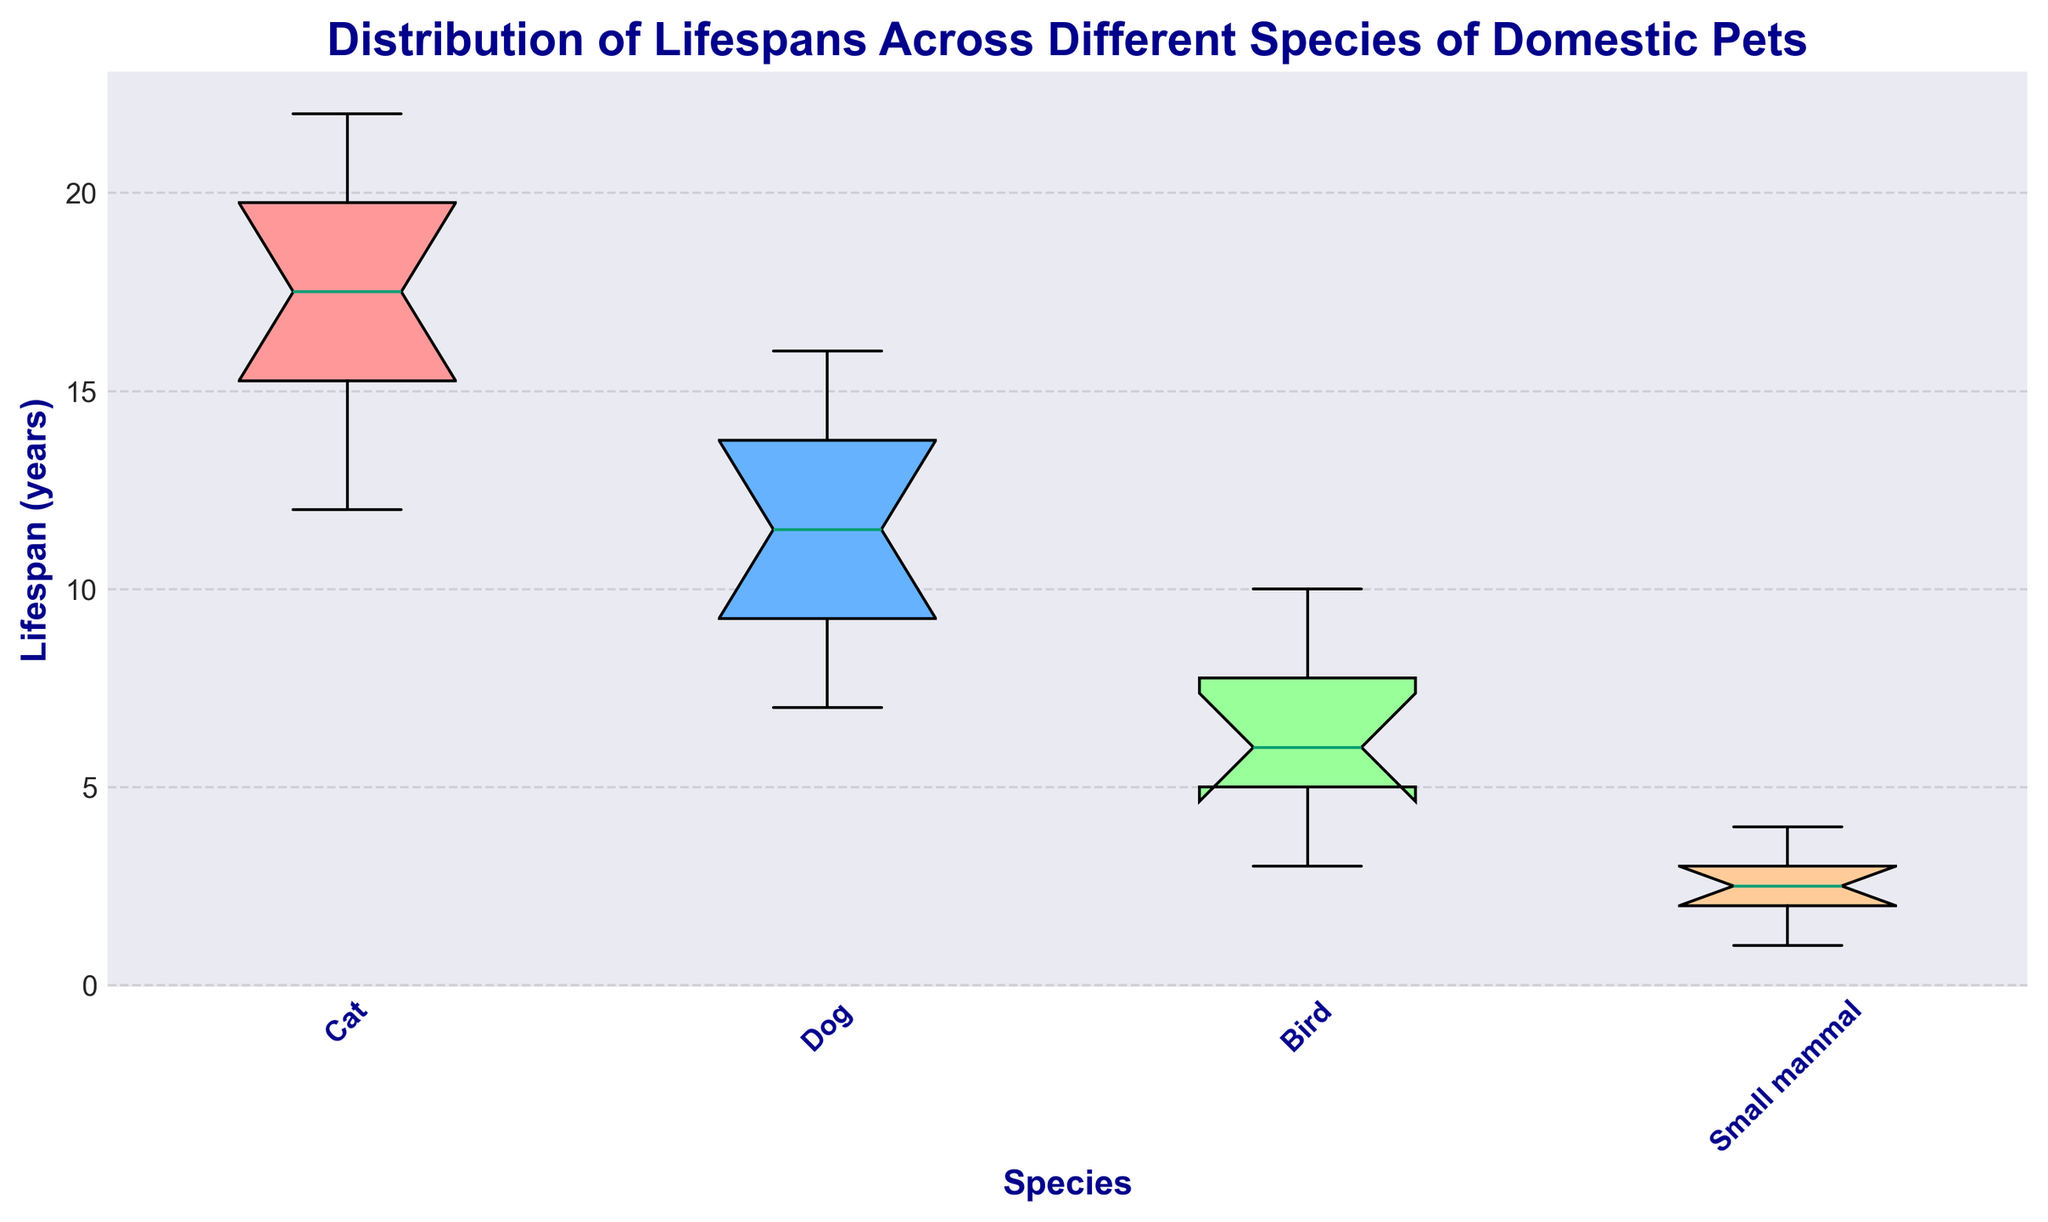What is the median lifespan of cats? The box plot displays the median value as the line inside the box for cats. Locate the box plot for cats and note the value where the line inside the box falls.
Answer: 18 Which species has the highest median lifespan? Compare the line inside the boxes of all species to identify which species has the tallest median value.
Answer: Cat Which species has the largest interquartile range (IQR) of lifespans? The IQR is represented by the length of the box. Compare the lengths of the boxes for all species to determine which one is the longest.
Answer: Dog What is the range of lifespans for small mammals? The range is the difference between the maximum and minimum values, represented by the whiskers' ends. Identify these values for small mammals and subtract the minimum from the maximum.
Answer: 3 Which species has the shortest upper whisker length in its box plot? The upper whisker length is the distance from the top of the box to the upper whisker end. Compare the upper whisker lengths for all species.
Answer: Bird How does the median lifespan of birds compare to that of dogs? Locate the line inside the boxes for both birds and dogs and compare their values to see which is higher or if they are equal.
Answer: Lower What is the interquartile range (IQR) of lifespans for birds? The IQR is the difference between the 75th percentile (top of the box) and the 25th percentile (bottom of the box). Measure this height difference for the bird's box plot.
Answer: 3 Which species has more variability in lifespans, cats or dogs? Variability can be inferred from the range (whisker to whisker) or the IQR (box size). Compare the width of the boxes and ranges of whiskers for cats and dogs.
Answer: Dogs How many species have a median lifespan above 10 years? Determine which species have their median line (inside the box) above the 10-year mark. Count these species.
Answer: 2 What is the overall range of lifespans for all species? Identify the minimum and maximum values across all species from the whiskers' ends and subtract the minimum from the maximum.
Answer: 19 